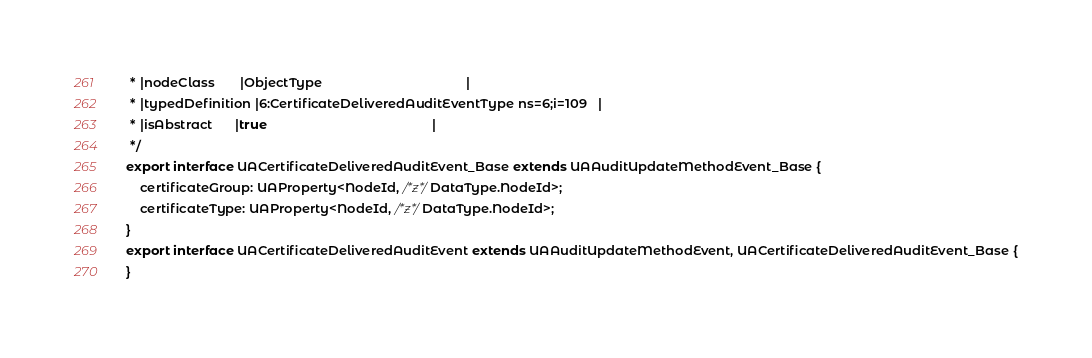<code> <loc_0><loc_0><loc_500><loc_500><_TypeScript_> * |nodeClass       |ObjectType                                        |
 * |typedDefinition |6:CertificateDeliveredAuditEventType ns=6;i=109   |
 * |isAbstract      |true                                              |
 */
export interface UACertificateDeliveredAuditEvent_Base extends UAAuditUpdateMethodEvent_Base {
    certificateGroup: UAProperty<NodeId, /*z*/DataType.NodeId>;
    certificateType: UAProperty<NodeId, /*z*/DataType.NodeId>;
}
export interface UACertificateDeliveredAuditEvent extends UAAuditUpdateMethodEvent, UACertificateDeliveredAuditEvent_Base {
}</code> 